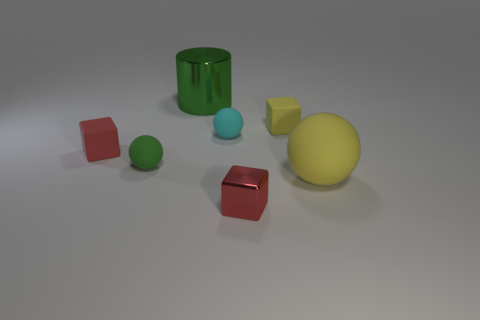There is a cube that is the same color as the big rubber thing; what is its material?
Your answer should be very brief. Rubber. The big object behind the red rubber object is what color?
Make the answer very short. Green. What size is the yellow matte sphere that is to the right of the red block that is behind the shiny cube?
Offer a terse response. Large. There is a yellow thing that is in front of the red rubber cube; is its shape the same as the tiny cyan matte object?
Your answer should be compact. Yes. There is another red thing that is the same shape as the red rubber thing; what is its material?
Your response must be concise. Metal. What number of objects are either small objects on the left side of the cylinder or tiny red blocks that are in front of the big matte ball?
Your answer should be very brief. 3. Is the color of the shiny cylinder the same as the rubber sphere that is on the left side of the large green shiny thing?
Ensure brevity in your answer.  Yes. What is the shape of the tiny cyan thing that is the same material as the tiny green thing?
Offer a terse response. Sphere. How many tiny red matte things are there?
Offer a very short reply. 1. What number of things are tiny red blocks that are behind the tiny red metal cube or cyan matte cubes?
Your answer should be compact. 1. 